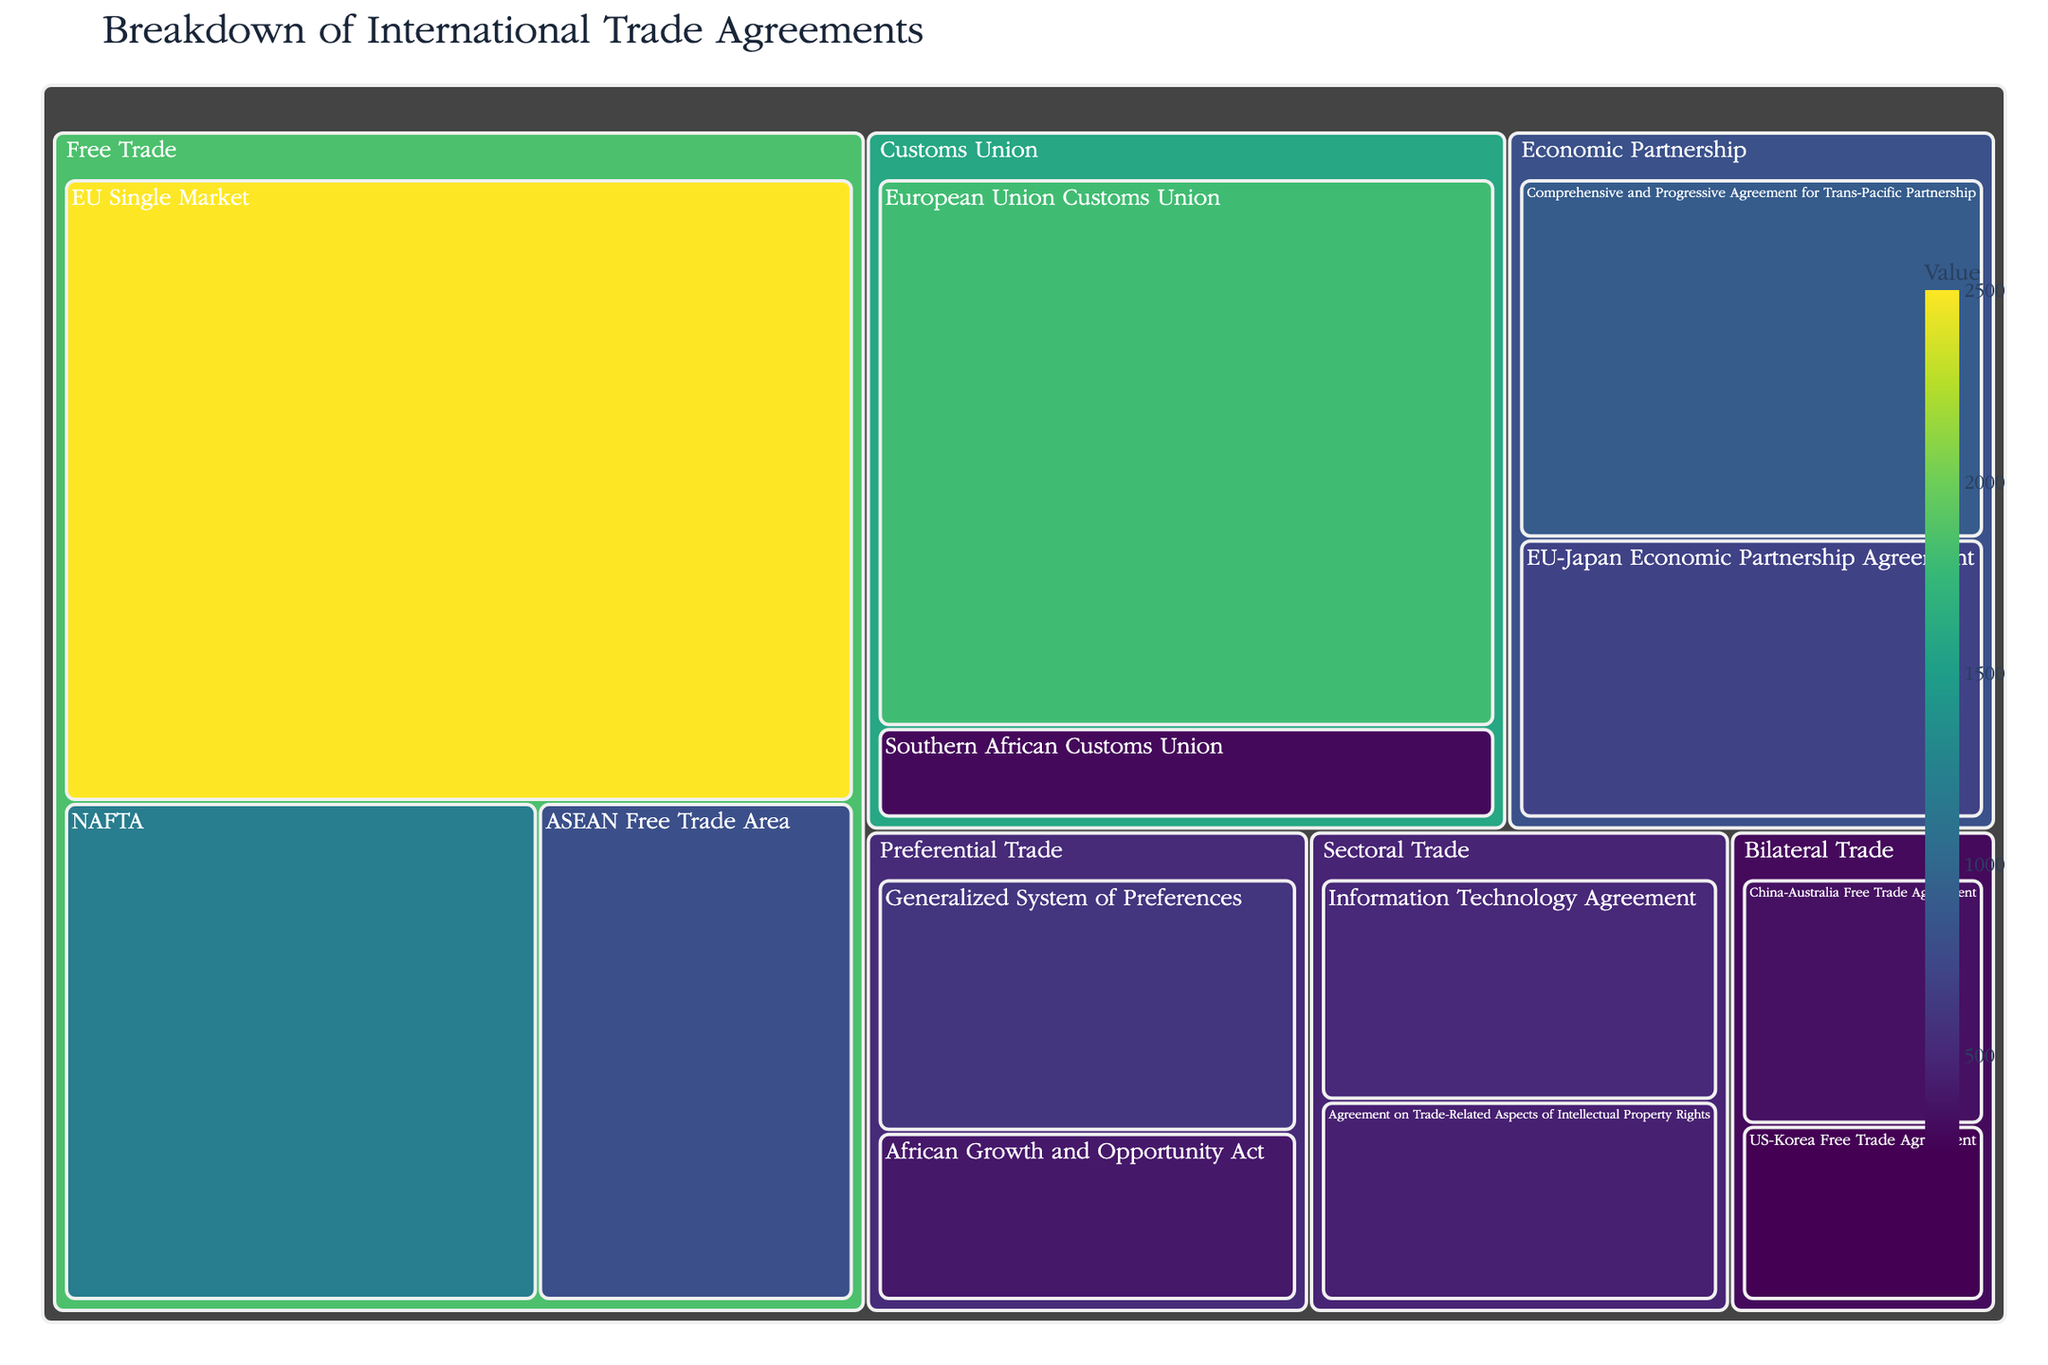What's the title of the figure? The title is displayed at the top of the treemap. It usually provides a summary of what the figure represents.
Answer: Breakdown of International Trade Agreements How many types of trade agreements are shown in the treemap? The types of trade agreements are the main categories shown as the first level of the treemap hierarchy. There are five such categories.
Answer: 5 Which trade agreement has the highest value? The largest rectangle, which would be the one with the highest value, is located within the "Free Trade" category and is colored distinctly due to the color scale.
Answer: EU Single Market What are the participating countries in the "NAFTA" agreement? By hovering over or identifying the "NAFTA" rectangle within the "Free Trade" category, the participating countries are listed in the hover data.
Answer: USA/Canada/Mexico What's the total value of all "Customs Union" agreements combined? To get the total value, sum up the individual values of all agreements under the "Customs Union" category. These values are 1800 and 300. So, 1800 + 300 = 2100
Answer: 2100 Compare the values of "Bilateral Trade" agreements between "US-Korea Free Trade Agreement" and "China-Australia Free Trade Agreement". Which one is higher? By looking at the relative sizes of the rectangles or checking the exact values in the hover data, we see that "China-Australia Free Trade Agreement" has a value of 350, which is higher than "US-Korea Free Trade Agreement" with a value of 250.
Answer: China-Australia Free Trade Agreement What's the combined value of all agreements in the "Sectoral Trade" category? Sum the values of the agreements under the "Sectoral Trade" category. These values are 500 and 450. So, 500 + 450 = 950
Answer: 950 Which free trade agreement has the smallest value? Within the "Free Trade" category, identify the smallest rectangle by either size or checking exact values. The smallest is "ASEAN Free Trade Area" with a value of 800.
Answer: ASEAN Free Trade Area What is the average value of all agreements in the "Preferential Trade" category? Calculate the average by summing the values of agreements under "Preferential Trade" (400 and 600) and then dividing by the number of agreements (2). So, (400 + 600) / 2 = 500
Answer: 500 What is the color scale used in the treemap? The description of the treemap indicates that the color scale is "Viridis," which provides a gradient color scale.
Answer: Viridis 